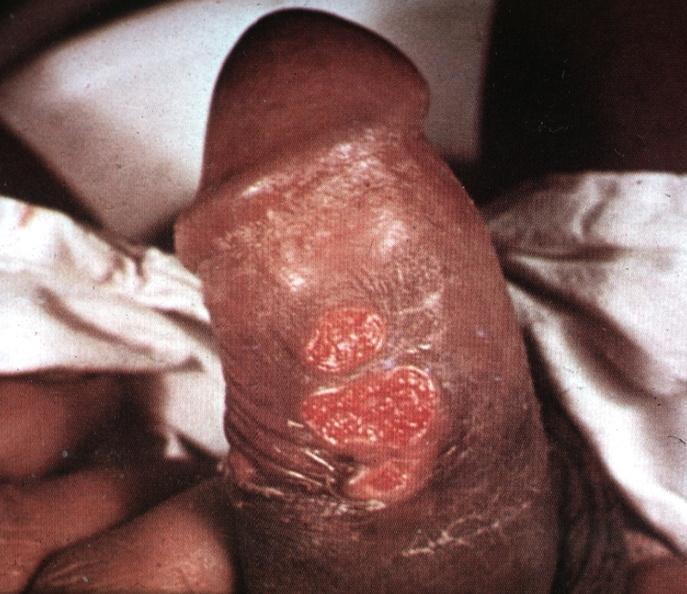s chancre present?
Answer the question using a single word or phrase. Yes 